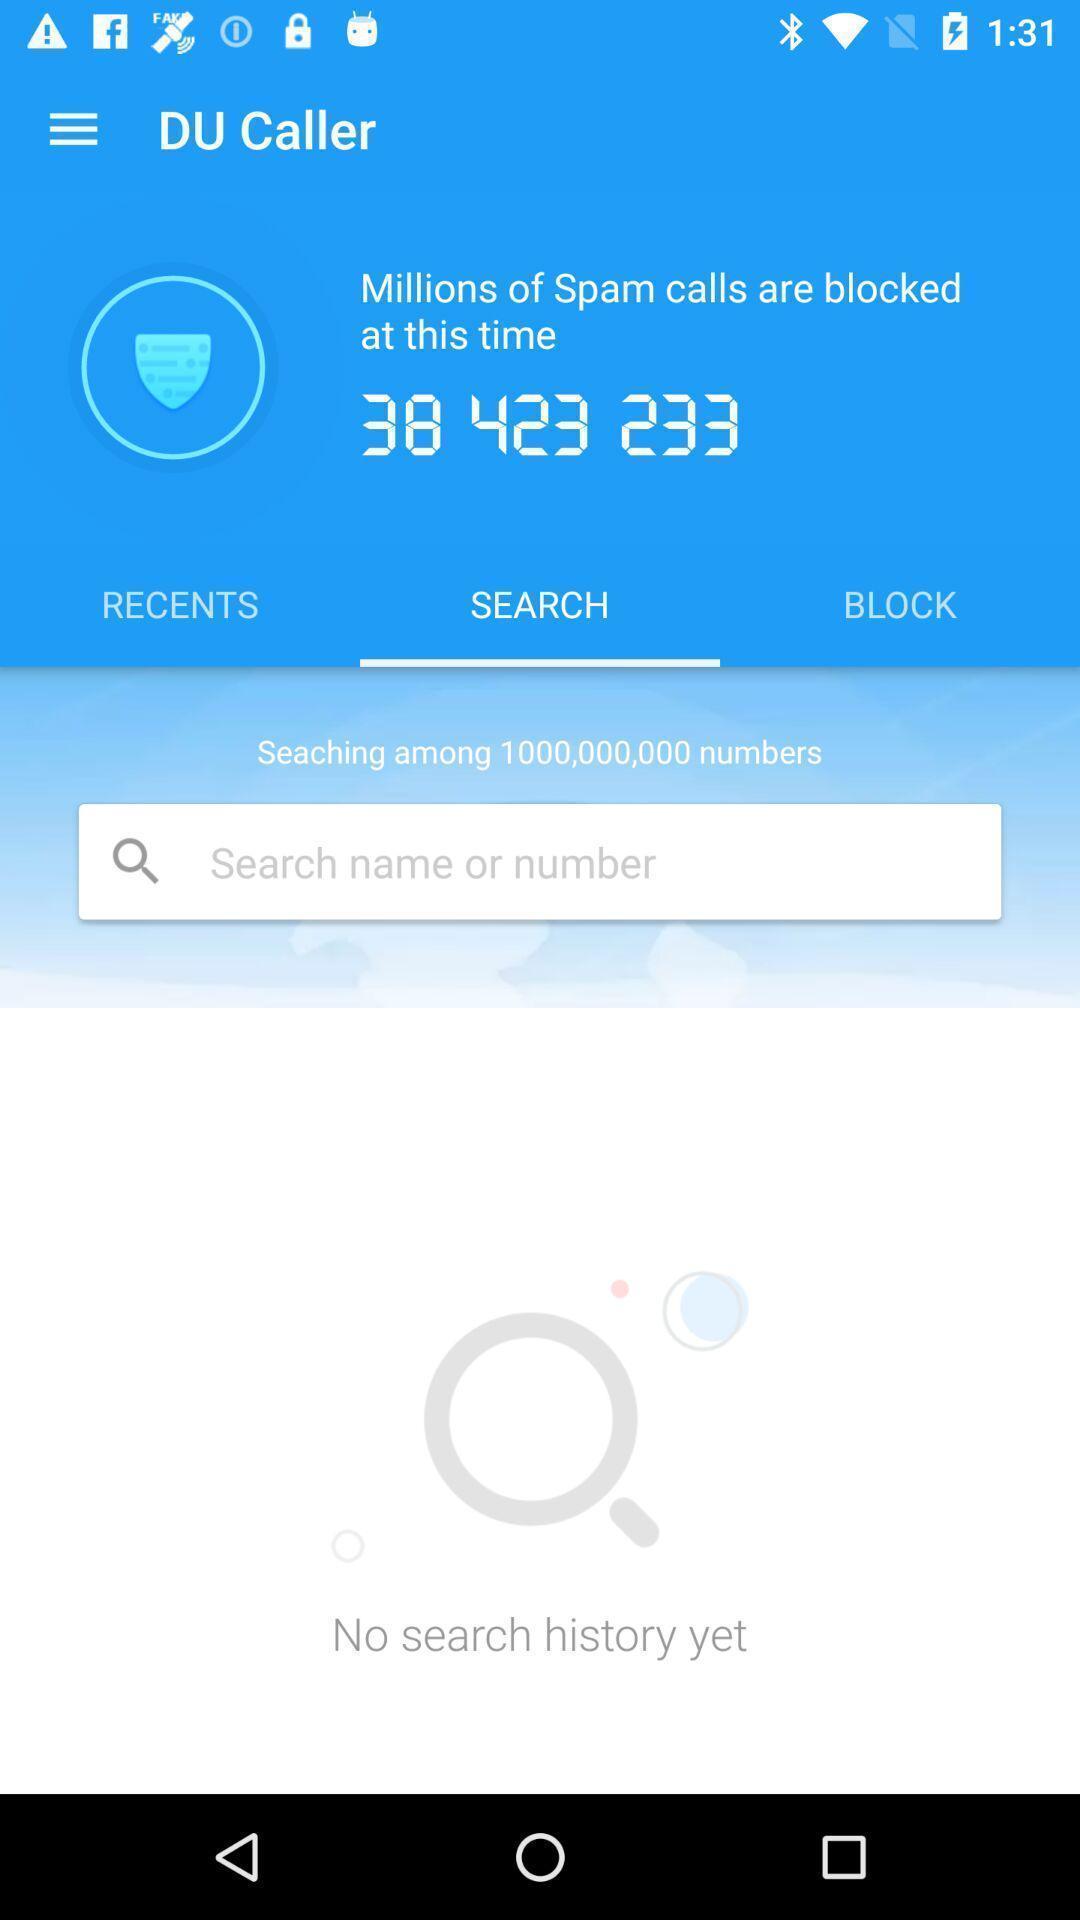Summarize the main components in this picture. Search bar of mobile numbers in caller app. 